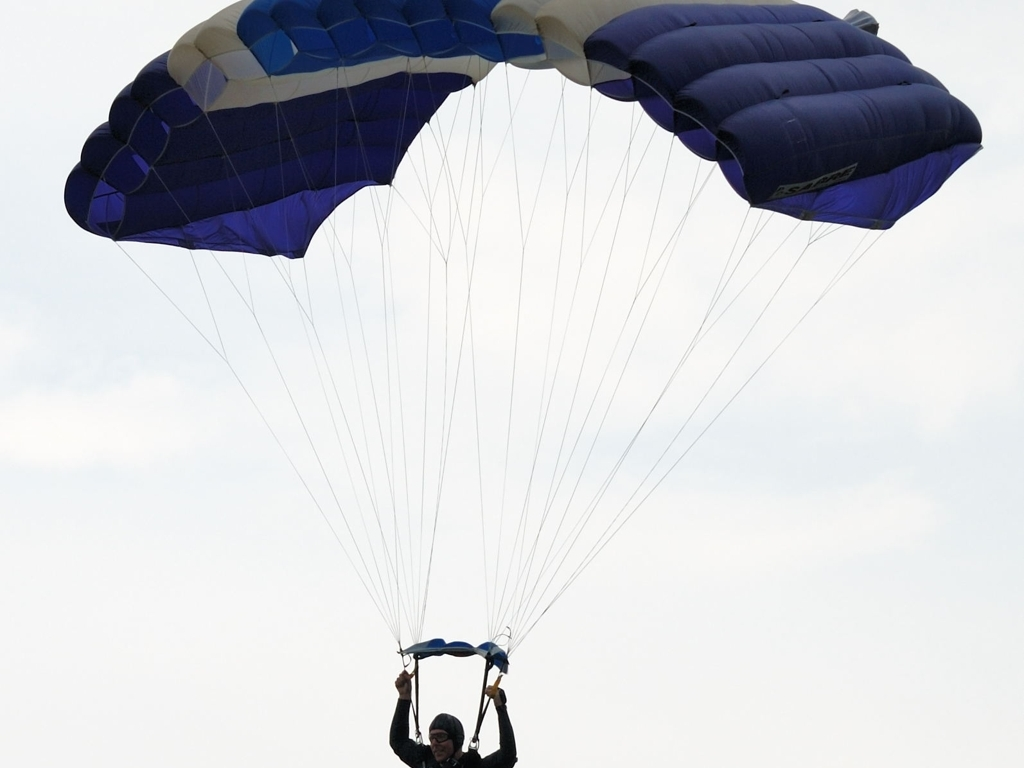How is the composition of the image? The composition of the image could be considered well-balanced. It captures the paraglider off-center, which adds a dynamic sense of movement to the scene. The negative space above and in front of the paraglider suggests direction and height. The choice to keep the paraglider away from the center draws our eyes across the picture, offering a better sense of scale and the vastness of the sky. Given these points, I would classify the composition as close to 'C. Well-balanced', rather than 'D. Not good'. 